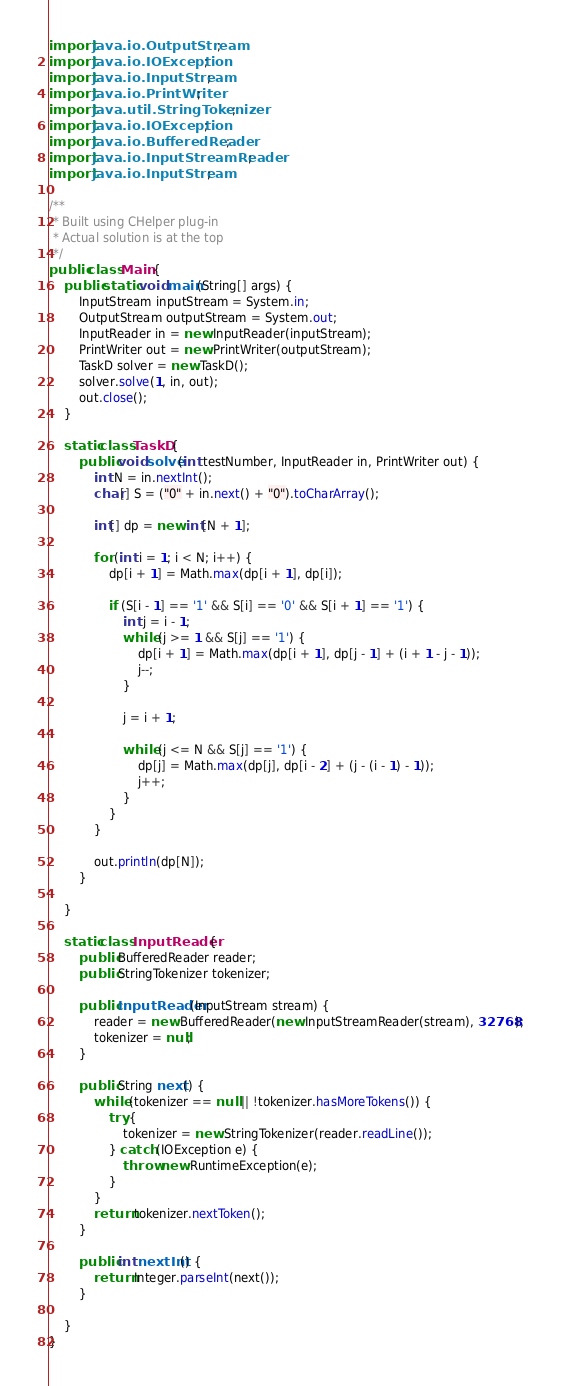Convert code to text. <code><loc_0><loc_0><loc_500><loc_500><_Java_>import java.io.OutputStream;
import java.io.IOException;
import java.io.InputStream;
import java.io.PrintWriter;
import java.util.StringTokenizer;
import java.io.IOException;
import java.io.BufferedReader;
import java.io.InputStreamReader;
import java.io.InputStream;

/**
 * Built using CHelper plug-in
 * Actual solution is at the top
 */
public class Main {
    public static void main(String[] args) {
        InputStream inputStream = System.in;
        OutputStream outputStream = System.out;
        InputReader in = new InputReader(inputStream);
        PrintWriter out = new PrintWriter(outputStream);
        TaskD solver = new TaskD();
        solver.solve(1, in, out);
        out.close();
    }

    static class TaskD {
        public void solve(int testNumber, InputReader in, PrintWriter out) {
            int N = in.nextInt();
            char[] S = ("0" + in.next() + "0").toCharArray();

            int[] dp = new int[N + 1];

            for (int i = 1; i < N; i++) {
                dp[i + 1] = Math.max(dp[i + 1], dp[i]);

                if (S[i - 1] == '1' && S[i] == '0' && S[i + 1] == '1') {
                    int j = i - 1;
                    while (j >= 1 && S[j] == '1') {
                        dp[i + 1] = Math.max(dp[i + 1], dp[j - 1] + (i + 1 - j - 1));
                        j--;
                    }

                    j = i + 1;

                    while (j <= N && S[j] == '1') {
                        dp[j] = Math.max(dp[j], dp[i - 2] + (j - (i - 1) - 1));
                        j++;
                    }
                }
            }

            out.println(dp[N]);
        }

    }

    static class InputReader {
        public BufferedReader reader;
        public StringTokenizer tokenizer;

        public InputReader(InputStream stream) {
            reader = new BufferedReader(new InputStreamReader(stream), 32768);
            tokenizer = null;
        }

        public String next() {
            while (tokenizer == null || !tokenizer.hasMoreTokens()) {
                try {
                    tokenizer = new StringTokenizer(reader.readLine());
                } catch (IOException e) {
                    throw new RuntimeException(e);
                }
            }
            return tokenizer.nextToken();
        }

        public int nextInt() {
            return Integer.parseInt(next());
        }

    }
}

</code> 